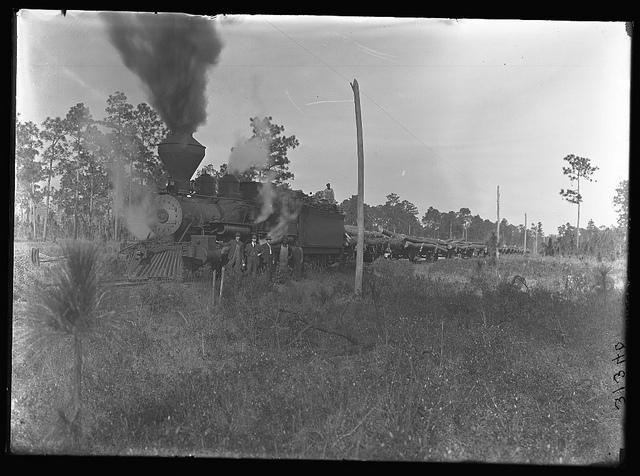How many trains are there?
Give a very brief answer. 1. How many keyboards are in the photo?
Give a very brief answer. 0. 